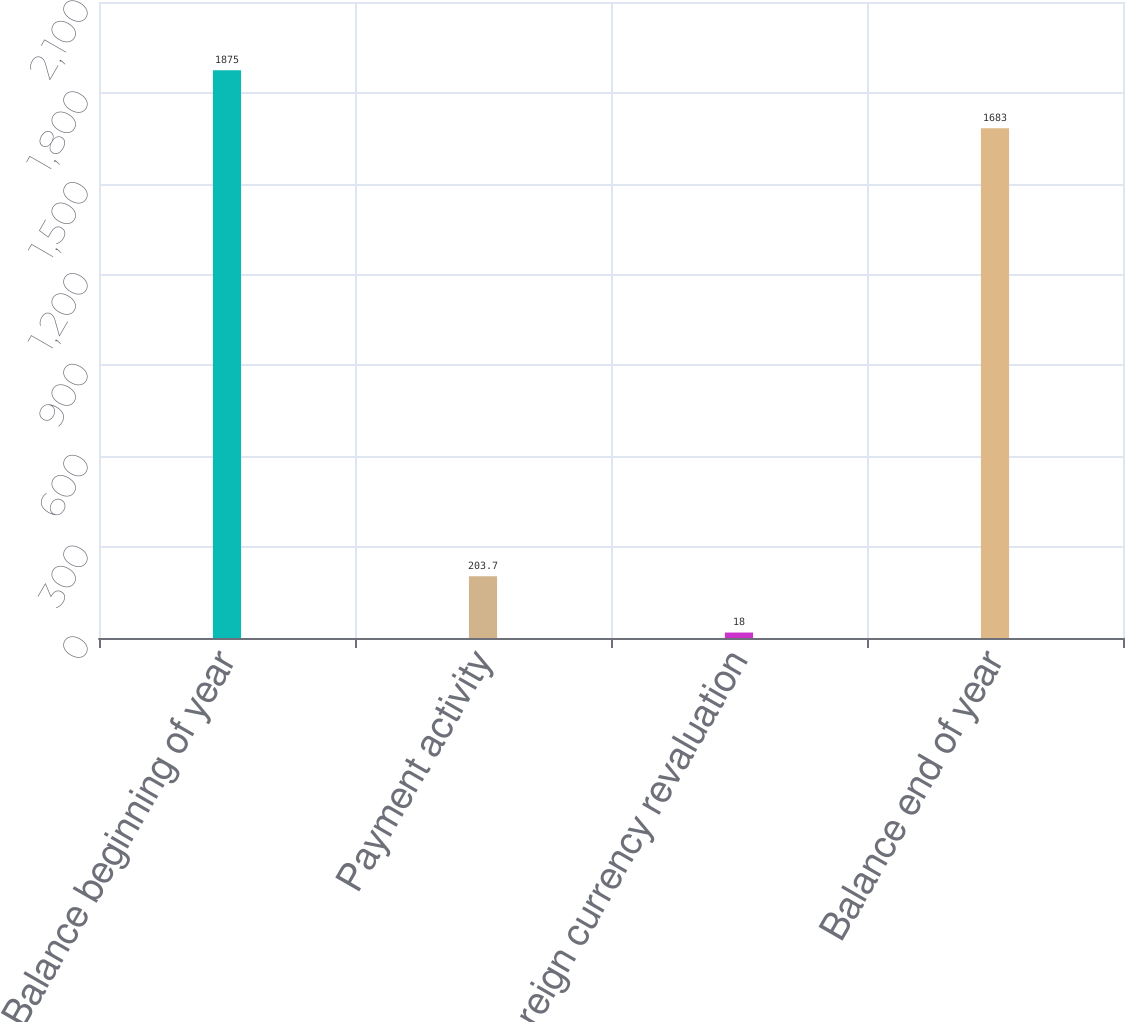Convert chart. <chart><loc_0><loc_0><loc_500><loc_500><bar_chart><fcel>Balance beginning of year<fcel>Payment activity<fcel>Foreign currency revaluation<fcel>Balance end of year<nl><fcel>1875<fcel>203.7<fcel>18<fcel>1683<nl></chart> 